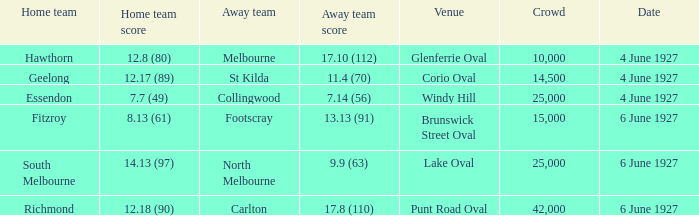When north melbourne is an away team, how many spectators are in the crowd? 25000.0. 